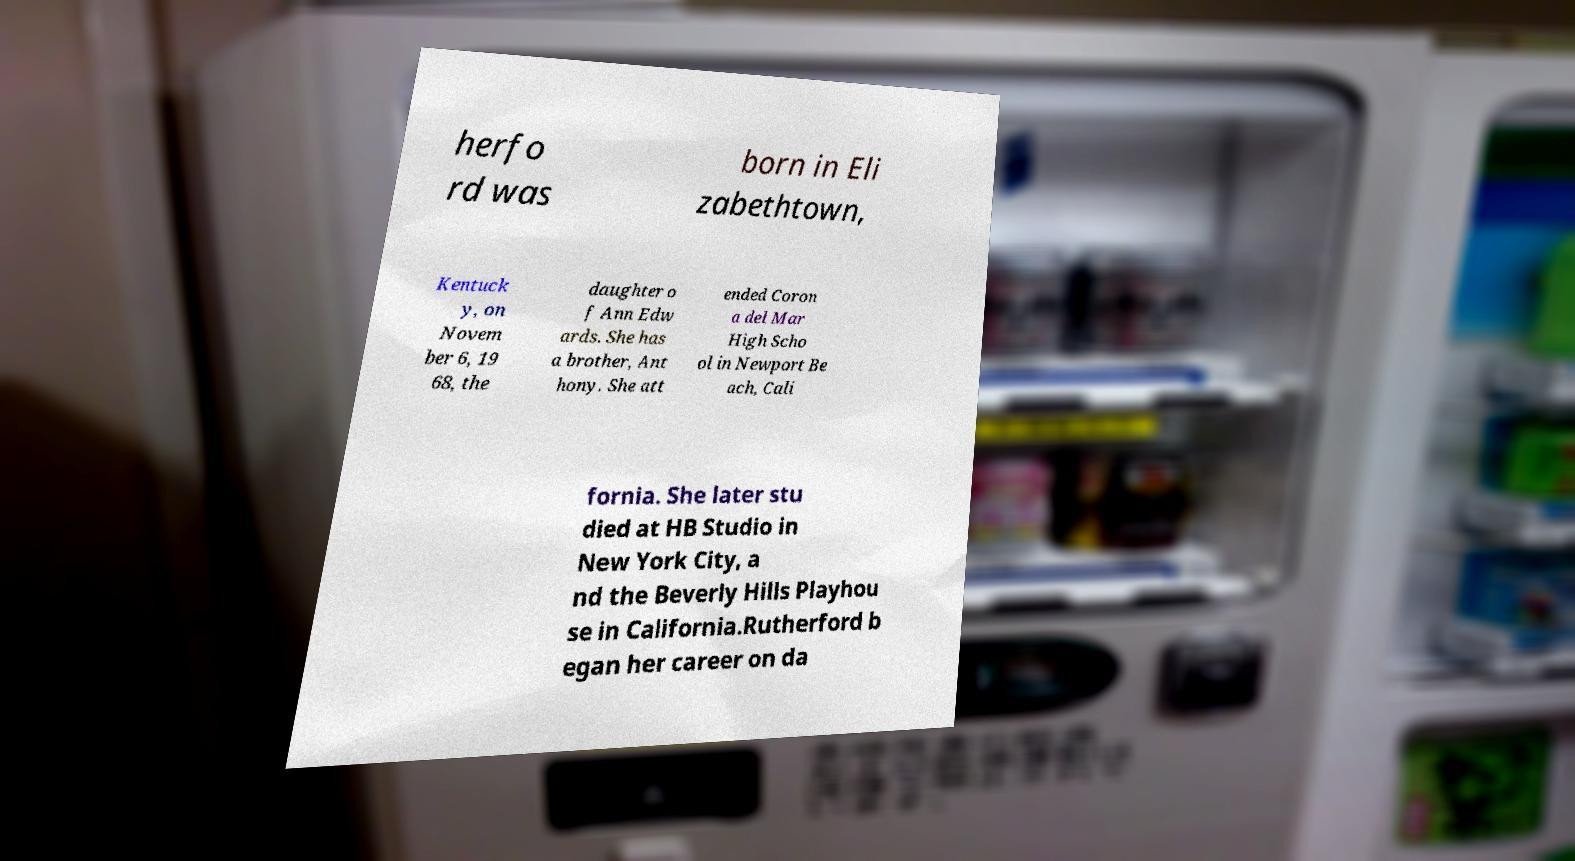There's text embedded in this image that I need extracted. Can you transcribe it verbatim? herfo rd was born in Eli zabethtown, Kentuck y, on Novem ber 6, 19 68, the daughter o f Ann Edw ards. She has a brother, Ant hony. She att ended Coron a del Mar High Scho ol in Newport Be ach, Cali fornia. She later stu died at HB Studio in New York City, a nd the Beverly Hills Playhou se in California.Rutherford b egan her career on da 